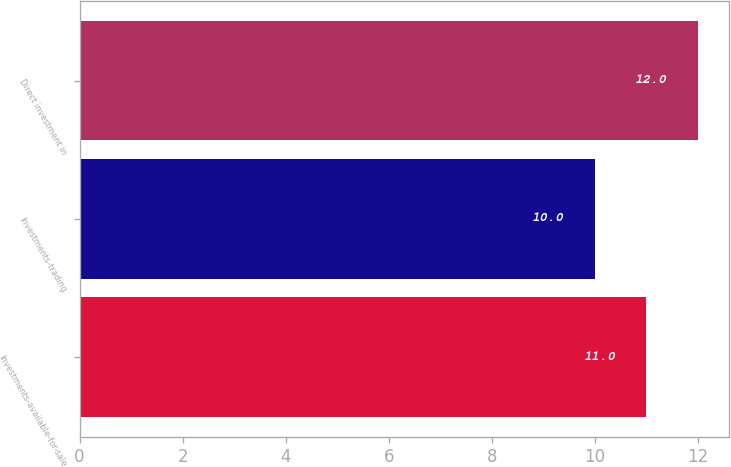<chart> <loc_0><loc_0><loc_500><loc_500><bar_chart><fcel>Investments-available-for-sale<fcel>Investments-trading<fcel>Direct investment in<nl><fcel>11<fcel>10<fcel>12<nl></chart> 